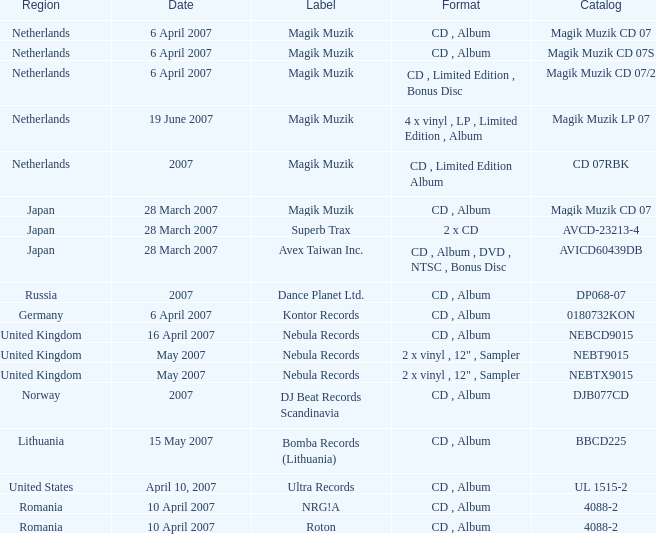Which label released the catalog Magik Muzik CD 07 on 28 March 2007? Magik Muzik. 